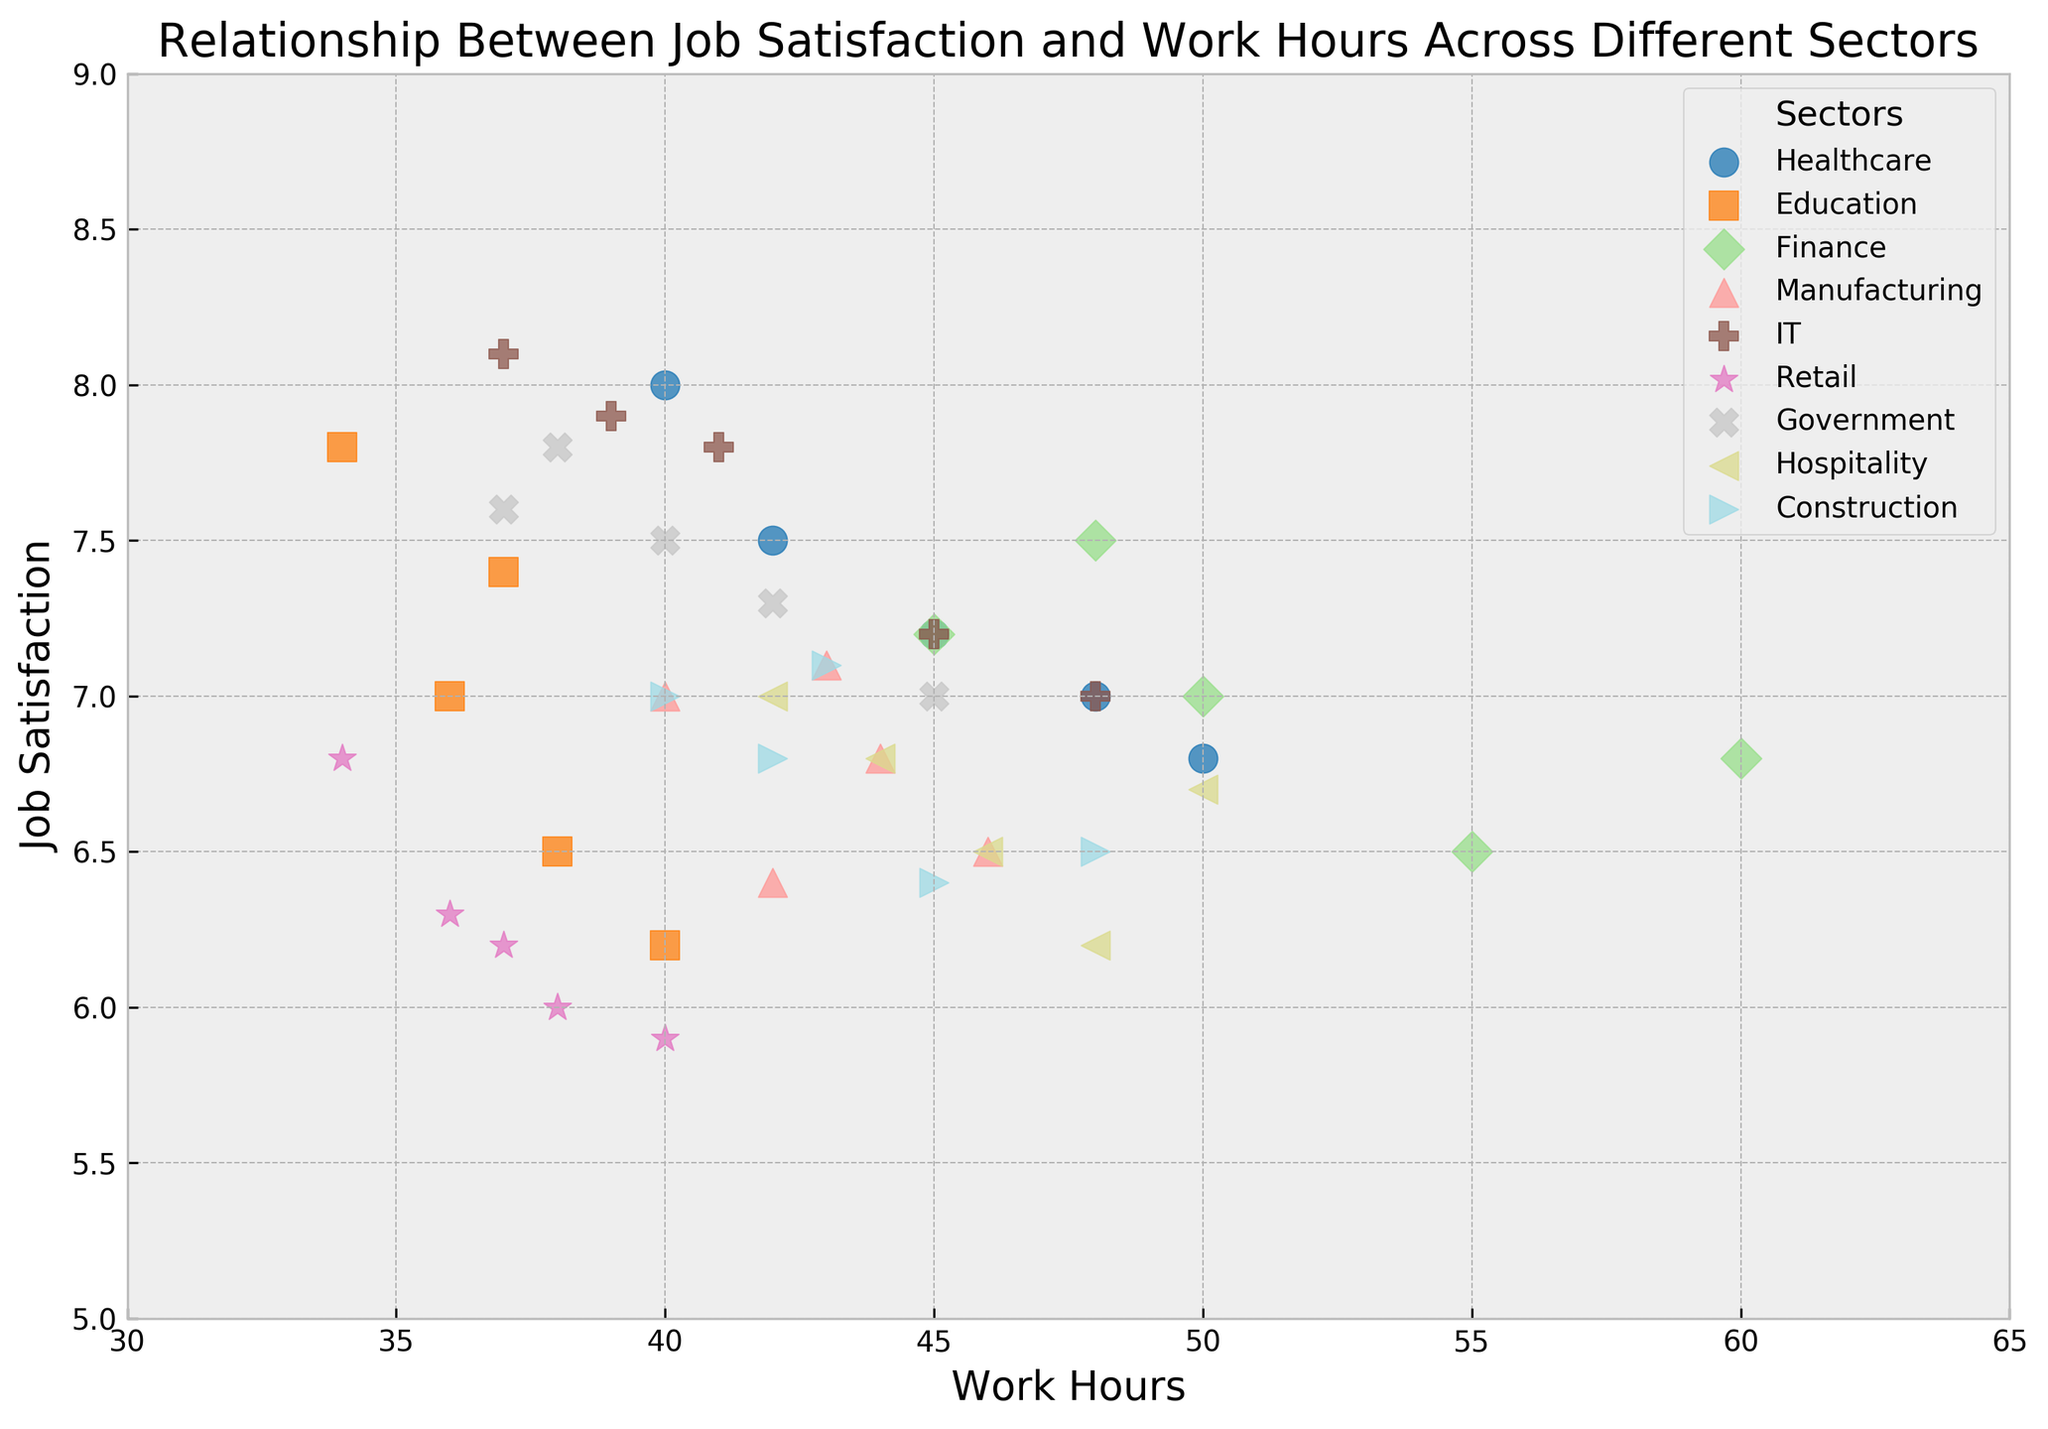What is the range of Job Satisfaction values in the Healthcare sector? To find the range, determine the minimum and maximum Job Satisfaction values in the Healthcare sector. The minimum is 6.8, and the maximum is 8.0, so the range is 8.0 - 6.8 = 1.2.
Answer: 1.2 Which sector has the highest average Job Satisfaction? First, calculate the average Job Satisfaction for each sector. Then compare the averages. IT has the highest average with values (7.8, 7.2, 7.9, 7.0, 8.1), with an average of (7.8 + 7.2 + 7.9 + 7.0 + 8.1)/5 = 7.6.
Answer: IT Are there any sectors where Job Satisfaction decreases as Work Hours increase? Scan through the scatter plot for any sector where the Job Satisfaction values show a decreasing trend with increasing Work Hours. In the Finance sector, Job Satisfaction appears to decrease as Work Hours increase.
Answer: Finance Which sector has the most clustered data points? Look for the sector where the data points are closest together. The data points for Education (6.5, 7.0, 7.8, 6.2, 7.4 with corresponding hours 38, 36, 34, 40, 37) are quite close, indicating clustering.
Answer: Education How does the average Work Hours in the Healthcare sector compare to that in the Retail sector? Calculate the average Work Hours for both sectors. Healthcare: (45+50+40+48+42)/5 = 45. Retail: (38+36+34+40+37)/5 = 37. Then compare the two averages, 45 (Healthcare) is greater than 37 (Retail).
Answer: Healthcare > Retail What is the difference in the maximum Job Satisfaction between the Retail and IT sectors? Identify the maximum Job Satisfaction in both sectors. For Retail, it is 6.8, and for IT, it is 8.1. The difference is 8.1 - 6.8 = 1.3.
Answer: 1.3 Which sector has the widest range of Work Hours? Determine the range of Work Hours by subtracting the minimum from the maximum for each sector and then compare. Finance has the widest range (60 - 45 = 15).
Answer: Finance In the Manufacturing sector, which data point has the highest Job Satisfaction and what are the corresponding Work Hours? Identify the data point with the highest Job Satisfaction in Manufacturing (7.1). The corresponding Work Hours are 43.
Answer: 43 Which sector has the lowest minimum Job Satisfaction value, and what is that value? Observe the minimum Job Satisfaction values across sectors. The lowest minimum is in the Retail sector, with a value of 5.9.
Answer: Retail, 5.9 In which sector does the data suggest that Job Satisfaction is relatively stable despite variations in Work Hours? Look for a sector with small variations in Job Satisfaction values across different Work Hours. The Government sector shows relatively stable Job Satisfaction values (ranging from 7.0 to 7.8) despite variations in Work Hours (40 to 45).
Answer: Government 